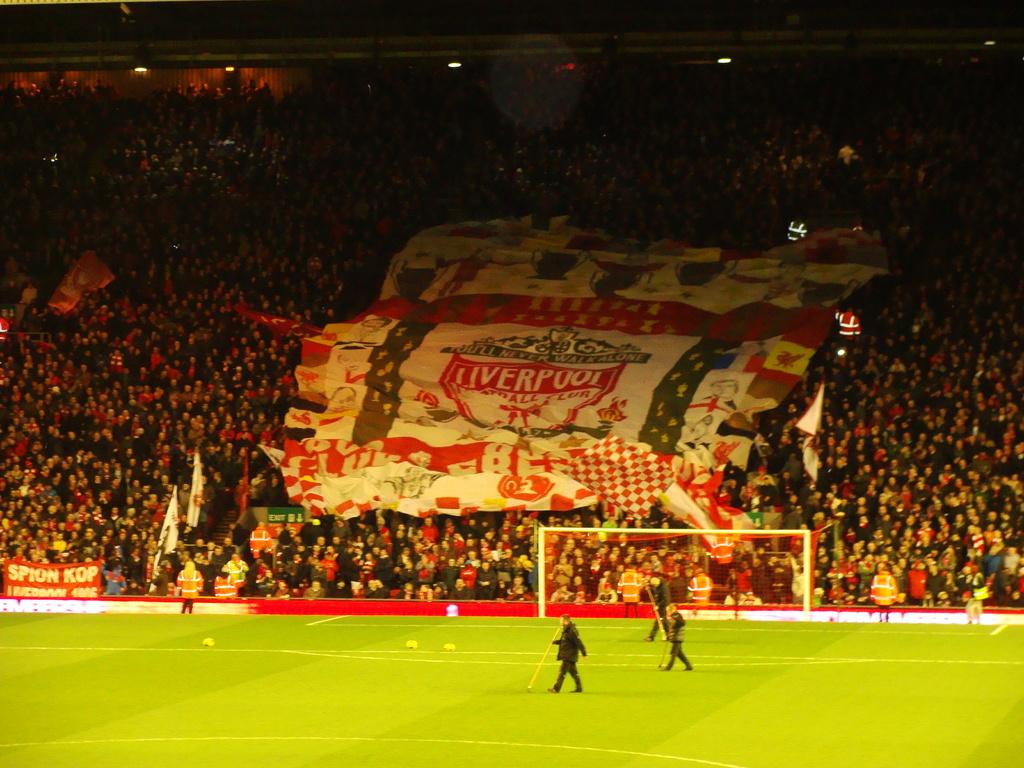What team do the fans supprt>?
Keep it short and to the point. Liverpool. What team is advertised?
Provide a short and direct response. Liverpool. 